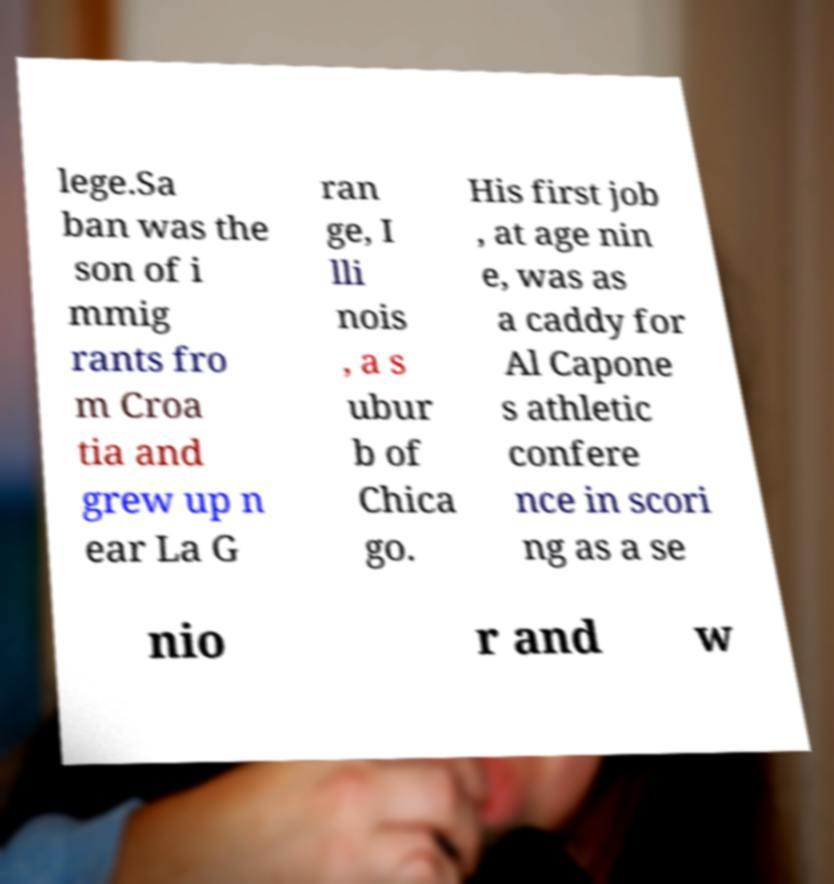I need the written content from this picture converted into text. Can you do that? lege.Sa ban was the son of i mmig rants fro m Croa tia and grew up n ear La G ran ge, I lli nois , a s ubur b of Chica go. His first job , at age nin e, was as a caddy for Al Capone s athletic confere nce in scori ng as a se nio r and w 